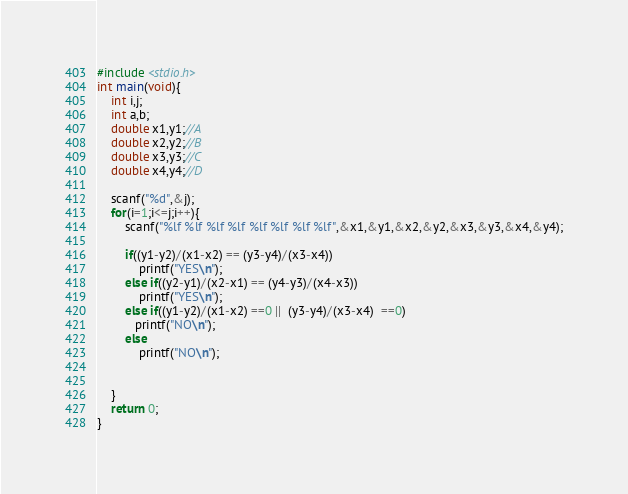Convert code to text. <code><loc_0><loc_0><loc_500><loc_500><_C_>#include <stdio.h>
int main(void){
    int i,j;
    int a,b;
    double x1,y1;//A
    double x2,y2;//B
    double x3,y3;//C
    double x4,y4;//D

    scanf("%d",&j);
    for(i=1;i<=j;i++){
        scanf("%lf %lf %lf %lf %lf %lf %lf %lf",&x1,&y1,&x2,&y2,&x3,&y3,&x4,&y4);

        if((y1-y2)/(x1-x2) == (y3-y4)/(x3-x4))
            printf("YES\n");
        else if((y2-y1)/(x2-x1) == (y4-y3)/(x4-x3))
            printf("YES\n");
        else if((y1-y2)/(x1-x2) ==0 ||  (y3-y4)/(x3-x4)  ==0)
           printf("NO\n");
        else
            printf("NO\n");
    
    
    }
    return 0;
}



</code> 